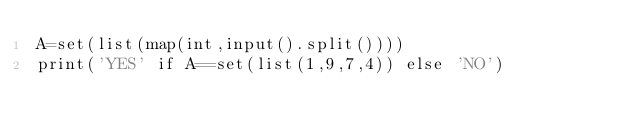Convert code to text. <code><loc_0><loc_0><loc_500><loc_500><_Python_>A=set(list(map(int,input().split())))
print('YES' if A==set(list(1,9,7,4)) else 'NO')</code> 